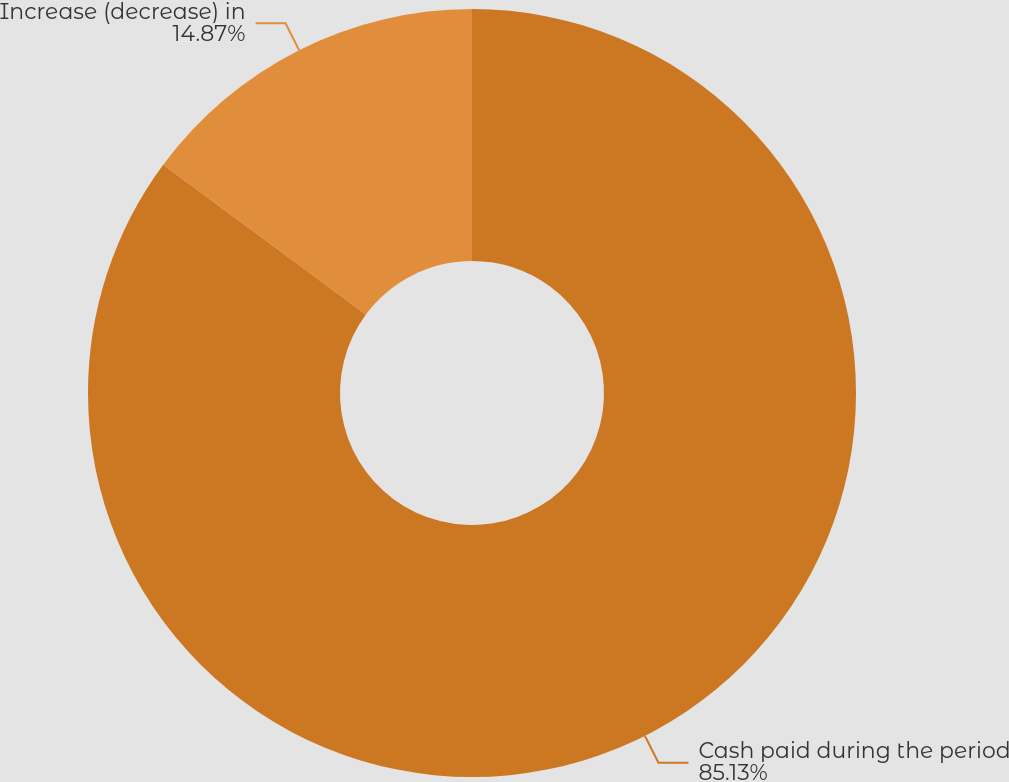Convert chart. <chart><loc_0><loc_0><loc_500><loc_500><pie_chart><fcel>Cash paid during the period<fcel>Increase (decrease) in<nl><fcel>85.13%<fcel>14.87%<nl></chart> 